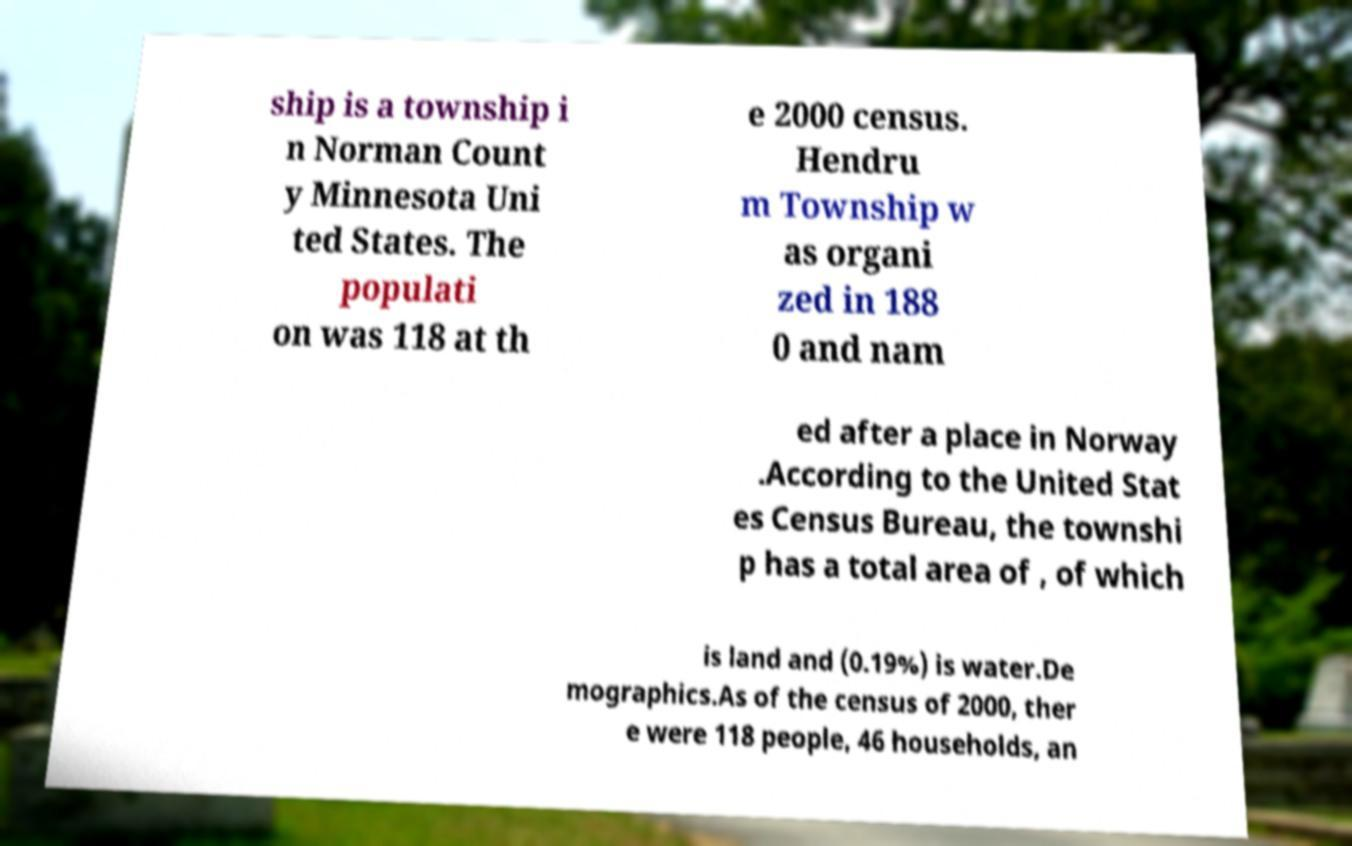What messages or text are displayed in this image? I need them in a readable, typed format. ship is a township i n Norman Count y Minnesota Uni ted States. The populati on was 118 at th e 2000 census. Hendru m Township w as organi zed in 188 0 and nam ed after a place in Norway .According to the United Stat es Census Bureau, the townshi p has a total area of , of which is land and (0.19%) is water.De mographics.As of the census of 2000, ther e were 118 people, 46 households, an 